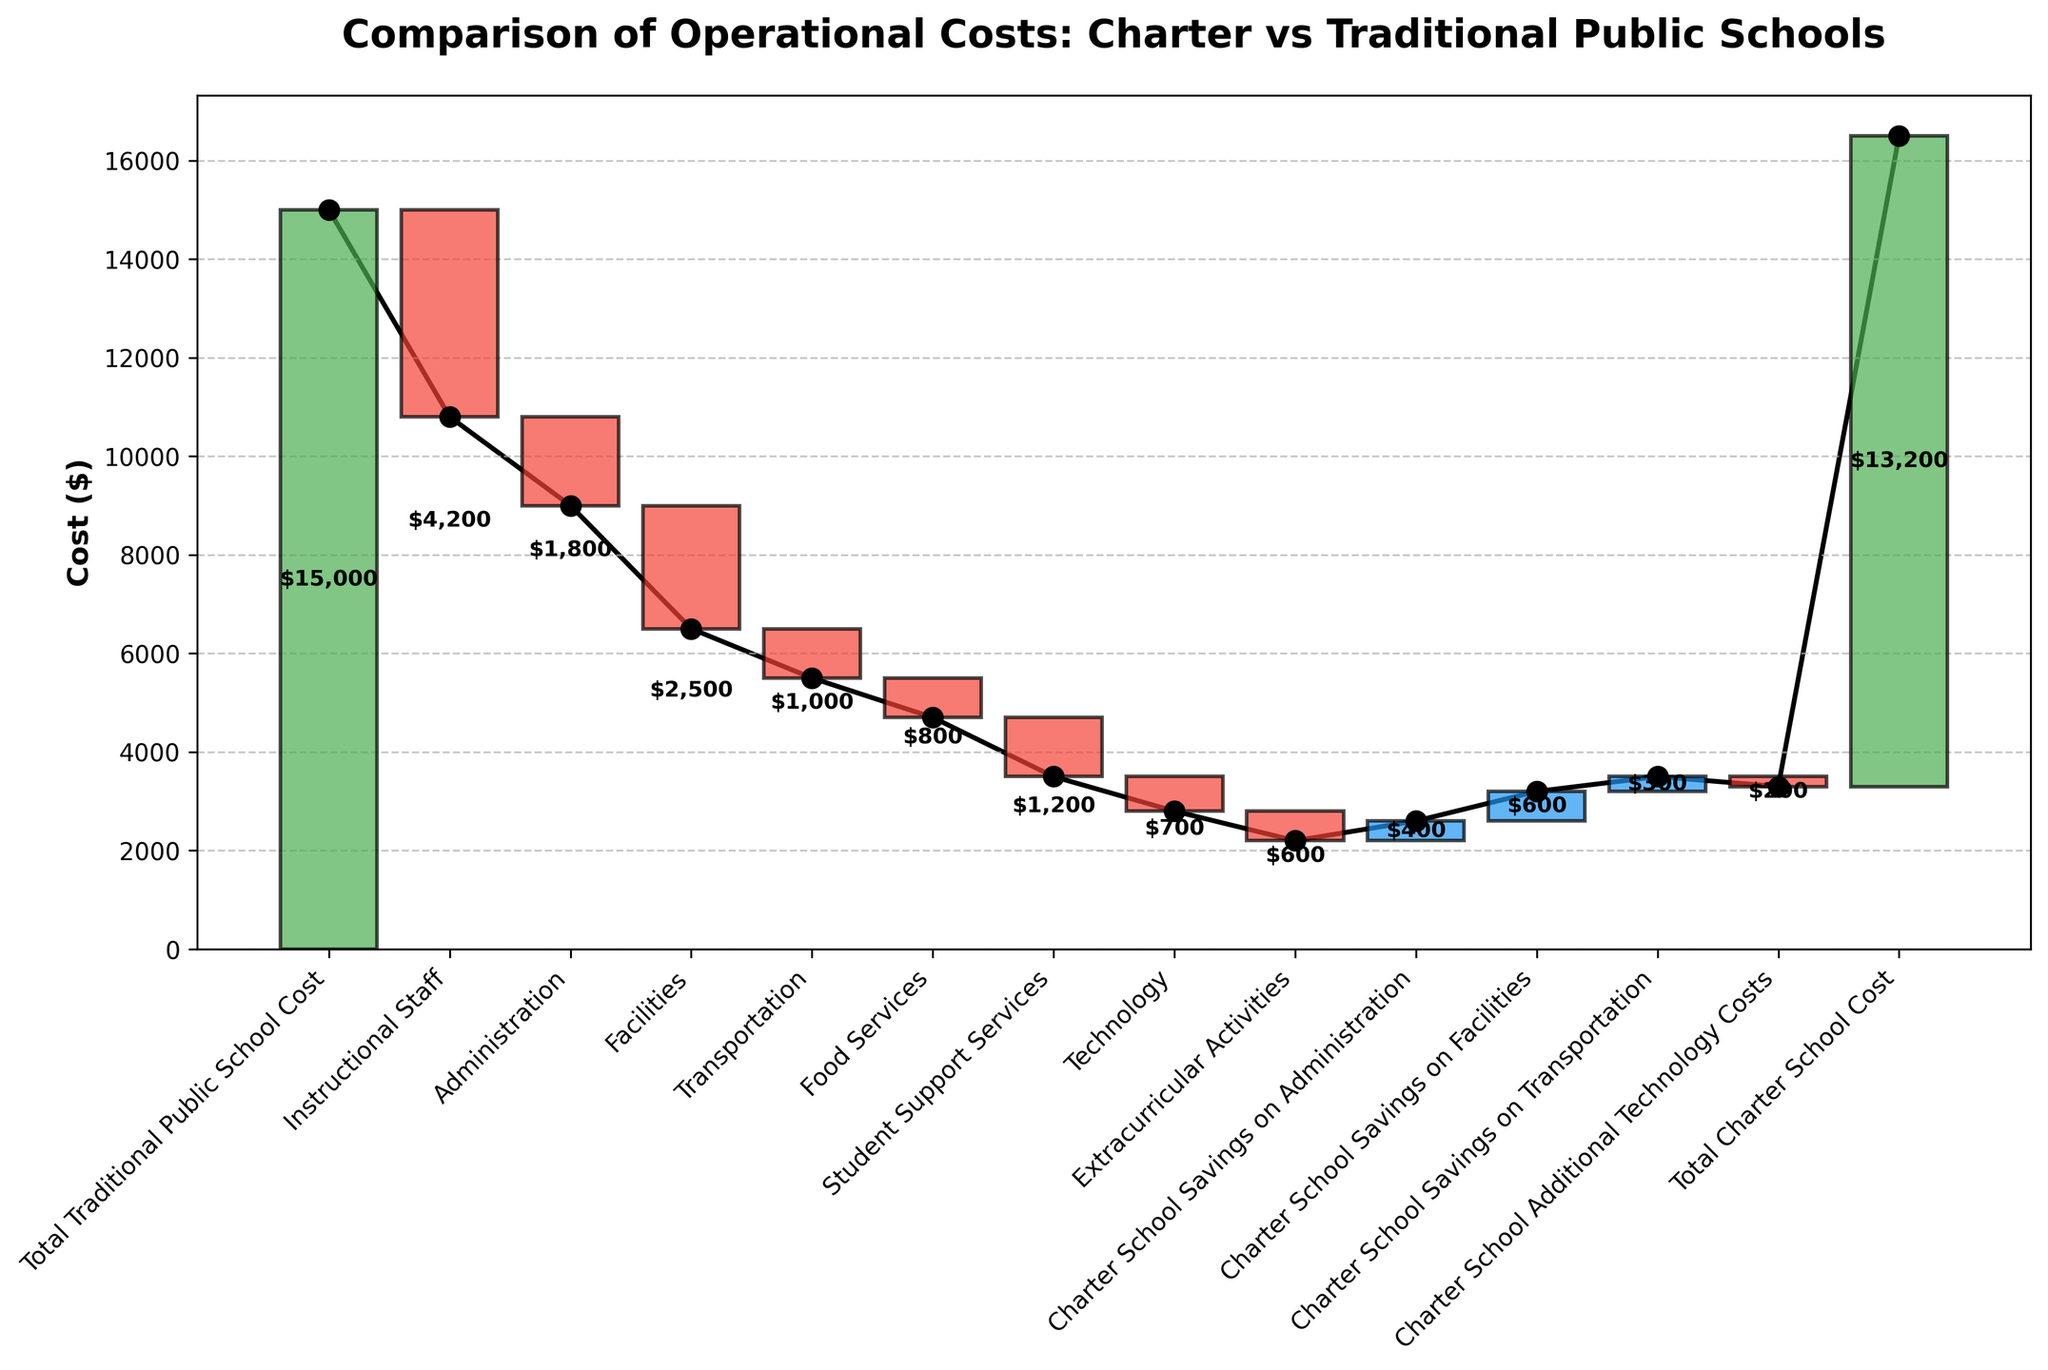What is the title of the figure? The title is displayed at the top of the chart, summarizing its purpose.
Answer: Comparison of Operational Costs: Charter vs Traditional Public Schools How does the cost of instructional staff compare to the total cost of traditional public school? According to the chart, the total cost for traditional public schools is represented by the starting green bar, and the instructional staff cost is represented by a red bar that signifies a deduction. The instructional staff costs $4,200, which reduces the total cost.
Answer: $4,200 less How much total savings do charter schools have on administration and facilities combined? According to the chart, charter schools save $400 on administration and $600 on facilities. Adding these amounts gives the total savings.
Answer: $1,000 Which category shows a higher value: charter school savings on facilities or charter school savings on transportation? The values shown on the blue bars for facilities and transportation savings indicate that charter school savings on facilities are higher at $600 compared to $300 for transportation.
Answer: Charter school savings on facilities What are the positive cost changes for charter schools shown in the chart? The chart shows positive values marked in blue and green bars, which include savings on administration, facilities, and transportation for charter schools. These values are $400, $600, and $300, respectively.
Answer: Administration, Facilities, Transportation How much extra do charter schools spend on technology according to the chart? The chart shows a red bar titled "Charter School Additional Technology Costs" indicating additional expenses. The value associated with this is -$200.
Answer: $200 What is the total cost difference between traditional public schools and charter schools? The total costs for traditional public schools and charter schools are shown as green bars at the beginning and end respectively, with values of $15,000 and $13,200. Subtracting these gives the difference.
Answer: $1,800 less By how much does the cost of extracurricular activities differ from student support services for traditional public schools? According to the chart, the cost for extracurricular activities is $600 and for student support services is $1,200. The difference is calculated by subtracting these values.
Answer: $600 less How is the cumulative cost affected by the administration cost in traditional public schools? The administration cost is represented by a red bar labeled "Administration," meaning it reduces the cumulative cost by the amount specified, which is $1,800.
Answer: Reduces by $1,800 Which category has the smallest financial impact on charter schools among those listed? The smallest value among the expenses/items listed for charter schools is shown by the blue bar in the chart, which is for transportation with a savings of $300.
Answer: Charter School Savings on Transportation 